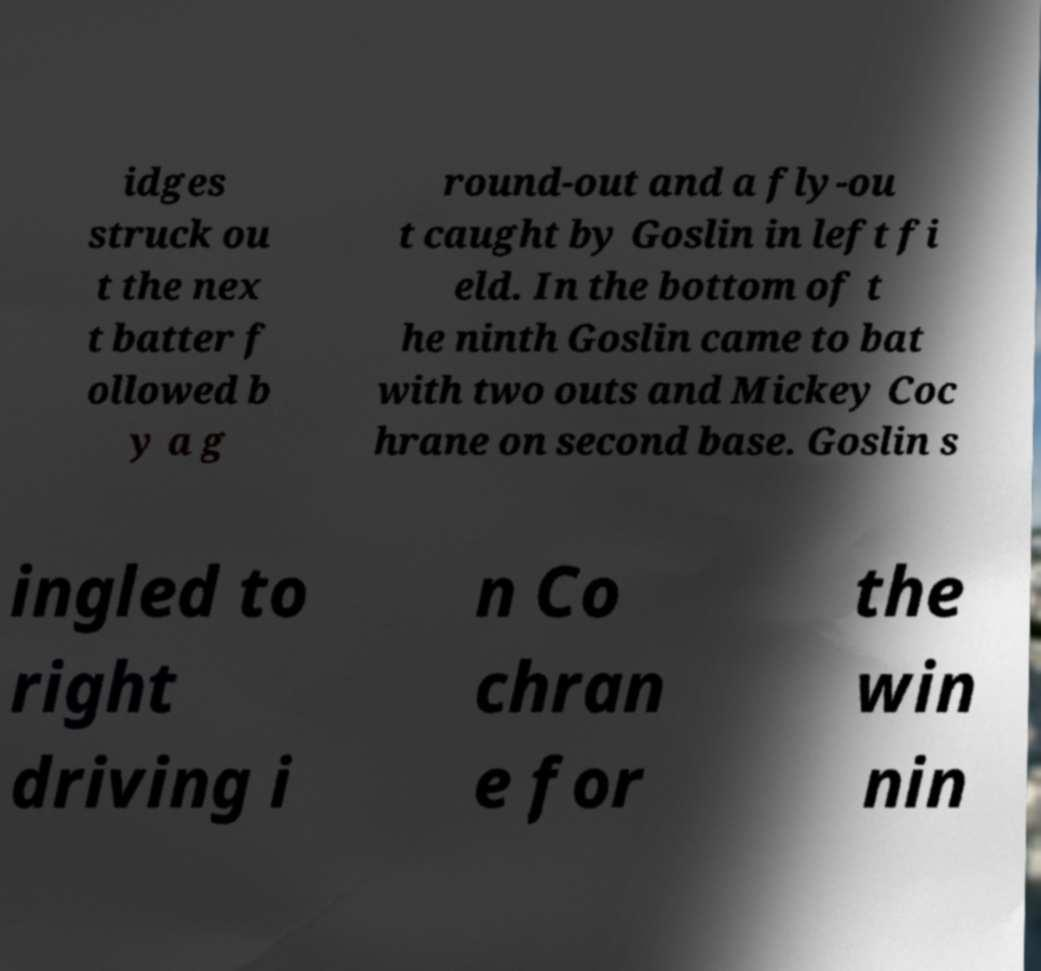Could you assist in decoding the text presented in this image and type it out clearly? idges struck ou t the nex t batter f ollowed b y a g round-out and a fly-ou t caught by Goslin in left fi eld. In the bottom of t he ninth Goslin came to bat with two outs and Mickey Coc hrane on second base. Goslin s ingled to right driving i n Co chran e for the win nin 